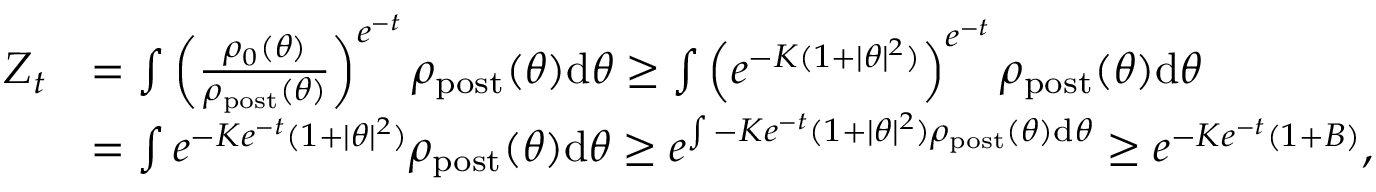Convert formula to latex. <formula><loc_0><loc_0><loc_500><loc_500>\begin{array} { r l } { Z _ { t } } & { = \int \left ( \frac { \rho _ { 0 } ( \theta ) } { \rho _ { p o s t } ( \theta ) } \right ) ^ { e ^ { - t } } \rho _ { p o s t } ( \theta ) d \theta \geq \int \left ( e ^ { - K ( 1 + | \theta | ^ { 2 } ) } \right ) ^ { e ^ { - t } } \rho _ { p o s t } ( \theta ) d \theta } \\ & { = \int e ^ { - K e ^ { - t } ( 1 + | \theta | ^ { 2 } ) } \rho _ { p o s t } ( \theta ) d \theta \geq e ^ { \int - K e ^ { - t } ( 1 + | \theta | ^ { 2 } ) \rho _ { p o s t } ( \theta ) d \theta } \geq e ^ { - K e ^ { - t } ( 1 + B ) } , } \end{array}</formula> 